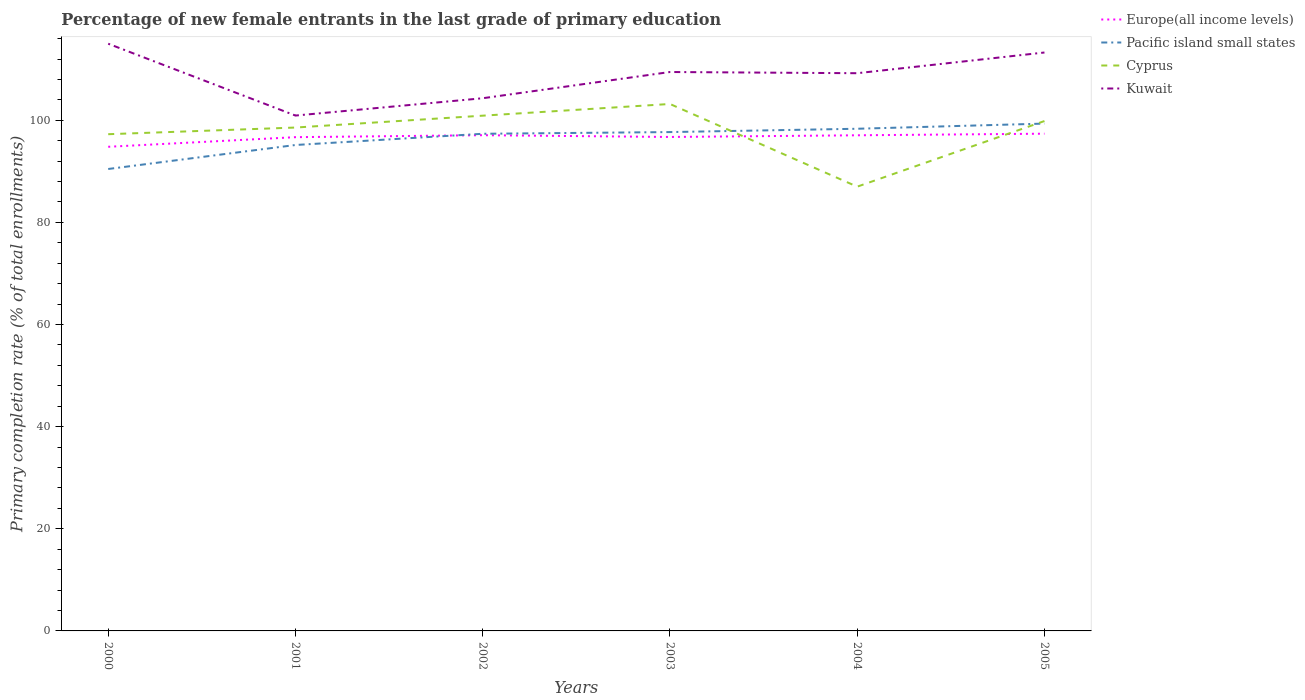Is the number of lines equal to the number of legend labels?
Provide a succinct answer. Yes. Across all years, what is the maximum percentage of new female entrants in Europe(all income levels)?
Ensure brevity in your answer.  94.81. In which year was the percentage of new female entrants in Cyprus maximum?
Offer a terse response. 2004. What is the total percentage of new female entrants in Kuwait in the graph?
Keep it short and to the point. -3.82. What is the difference between the highest and the second highest percentage of new female entrants in Kuwait?
Offer a very short reply. 14.07. What is the difference between the highest and the lowest percentage of new female entrants in Pacific island small states?
Offer a very short reply. 4. Is the percentage of new female entrants in Europe(all income levels) strictly greater than the percentage of new female entrants in Kuwait over the years?
Offer a terse response. Yes. Are the values on the major ticks of Y-axis written in scientific E-notation?
Provide a short and direct response. No. Does the graph contain any zero values?
Ensure brevity in your answer.  No. Where does the legend appear in the graph?
Offer a terse response. Top right. What is the title of the graph?
Offer a very short reply. Percentage of new female entrants in the last grade of primary education. Does "Syrian Arab Republic" appear as one of the legend labels in the graph?
Provide a succinct answer. No. What is the label or title of the Y-axis?
Make the answer very short. Primary completion rate (% of total enrollments). What is the Primary completion rate (% of total enrollments) of Europe(all income levels) in 2000?
Keep it short and to the point. 94.81. What is the Primary completion rate (% of total enrollments) in Pacific island small states in 2000?
Provide a succinct answer. 90.46. What is the Primary completion rate (% of total enrollments) in Cyprus in 2000?
Your response must be concise. 97.27. What is the Primary completion rate (% of total enrollments) in Kuwait in 2000?
Provide a short and direct response. 114.99. What is the Primary completion rate (% of total enrollments) in Europe(all income levels) in 2001?
Keep it short and to the point. 96.69. What is the Primary completion rate (% of total enrollments) of Pacific island small states in 2001?
Offer a very short reply. 95.16. What is the Primary completion rate (% of total enrollments) in Cyprus in 2001?
Offer a terse response. 98.58. What is the Primary completion rate (% of total enrollments) in Kuwait in 2001?
Keep it short and to the point. 100.93. What is the Primary completion rate (% of total enrollments) of Europe(all income levels) in 2002?
Ensure brevity in your answer.  97.08. What is the Primary completion rate (% of total enrollments) in Pacific island small states in 2002?
Your answer should be compact. 97.36. What is the Primary completion rate (% of total enrollments) in Cyprus in 2002?
Provide a short and direct response. 100.9. What is the Primary completion rate (% of total enrollments) of Kuwait in 2002?
Ensure brevity in your answer.  104.32. What is the Primary completion rate (% of total enrollments) in Europe(all income levels) in 2003?
Make the answer very short. 96.73. What is the Primary completion rate (% of total enrollments) of Pacific island small states in 2003?
Make the answer very short. 97.69. What is the Primary completion rate (% of total enrollments) of Cyprus in 2003?
Offer a very short reply. 103.19. What is the Primary completion rate (% of total enrollments) of Kuwait in 2003?
Provide a short and direct response. 109.45. What is the Primary completion rate (% of total enrollments) of Europe(all income levels) in 2004?
Give a very brief answer. 97.06. What is the Primary completion rate (% of total enrollments) of Pacific island small states in 2004?
Provide a short and direct response. 98.34. What is the Primary completion rate (% of total enrollments) in Cyprus in 2004?
Offer a very short reply. 87. What is the Primary completion rate (% of total enrollments) in Kuwait in 2004?
Offer a terse response. 109.22. What is the Primary completion rate (% of total enrollments) in Europe(all income levels) in 2005?
Offer a terse response. 97.37. What is the Primary completion rate (% of total enrollments) in Pacific island small states in 2005?
Keep it short and to the point. 99.35. What is the Primary completion rate (% of total enrollments) of Cyprus in 2005?
Ensure brevity in your answer.  99.85. What is the Primary completion rate (% of total enrollments) in Kuwait in 2005?
Make the answer very short. 113.27. Across all years, what is the maximum Primary completion rate (% of total enrollments) in Europe(all income levels)?
Give a very brief answer. 97.37. Across all years, what is the maximum Primary completion rate (% of total enrollments) of Pacific island small states?
Make the answer very short. 99.35. Across all years, what is the maximum Primary completion rate (% of total enrollments) in Cyprus?
Keep it short and to the point. 103.19. Across all years, what is the maximum Primary completion rate (% of total enrollments) of Kuwait?
Keep it short and to the point. 114.99. Across all years, what is the minimum Primary completion rate (% of total enrollments) of Europe(all income levels)?
Provide a succinct answer. 94.81. Across all years, what is the minimum Primary completion rate (% of total enrollments) in Pacific island small states?
Ensure brevity in your answer.  90.46. Across all years, what is the minimum Primary completion rate (% of total enrollments) of Cyprus?
Make the answer very short. 87. Across all years, what is the minimum Primary completion rate (% of total enrollments) in Kuwait?
Provide a succinct answer. 100.93. What is the total Primary completion rate (% of total enrollments) of Europe(all income levels) in the graph?
Ensure brevity in your answer.  579.75. What is the total Primary completion rate (% of total enrollments) of Pacific island small states in the graph?
Your response must be concise. 578.36. What is the total Primary completion rate (% of total enrollments) of Cyprus in the graph?
Keep it short and to the point. 586.8. What is the total Primary completion rate (% of total enrollments) of Kuwait in the graph?
Offer a terse response. 652.18. What is the difference between the Primary completion rate (% of total enrollments) of Europe(all income levels) in 2000 and that in 2001?
Offer a terse response. -1.88. What is the difference between the Primary completion rate (% of total enrollments) of Pacific island small states in 2000 and that in 2001?
Ensure brevity in your answer.  -4.7. What is the difference between the Primary completion rate (% of total enrollments) in Cyprus in 2000 and that in 2001?
Ensure brevity in your answer.  -1.31. What is the difference between the Primary completion rate (% of total enrollments) of Kuwait in 2000 and that in 2001?
Your response must be concise. 14.07. What is the difference between the Primary completion rate (% of total enrollments) of Europe(all income levels) in 2000 and that in 2002?
Offer a very short reply. -2.27. What is the difference between the Primary completion rate (% of total enrollments) in Pacific island small states in 2000 and that in 2002?
Provide a short and direct response. -6.9. What is the difference between the Primary completion rate (% of total enrollments) in Cyprus in 2000 and that in 2002?
Give a very brief answer. -3.63. What is the difference between the Primary completion rate (% of total enrollments) of Kuwait in 2000 and that in 2002?
Provide a succinct answer. 10.68. What is the difference between the Primary completion rate (% of total enrollments) in Europe(all income levels) in 2000 and that in 2003?
Ensure brevity in your answer.  -1.92. What is the difference between the Primary completion rate (% of total enrollments) in Pacific island small states in 2000 and that in 2003?
Give a very brief answer. -7.23. What is the difference between the Primary completion rate (% of total enrollments) of Cyprus in 2000 and that in 2003?
Ensure brevity in your answer.  -5.92. What is the difference between the Primary completion rate (% of total enrollments) of Kuwait in 2000 and that in 2003?
Offer a terse response. 5.54. What is the difference between the Primary completion rate (% of total enrollments) in Europe(all income levels) in 2000 and that in 2004?
Offer a terse response. -2.25. What is the difference between the Primary completion rate (% of total enrollments) in Pacific island small states in 2000 and that in 2004?
Your response must be concise. -7.88. What is the difference between the Primary completion rate (% of total enrollments) in Cyprus in 2000 and that in 2004?
Give a very brief answer. 10.27. What is the difference between the Primary completion rate (% of total enrollments) of Kuwait in 2000 and that in 2004?
Make the answer very short. 5.78. What is the difference between the Primary completion rate (% of total enrollments) in Europe(all income levels) in 2000 and that in 2005?
Your answer should be compact. -2.56. What is the difference between the Primary completion rate (% of total enrollments) of Pacific island small states in 2000 and that in 2005?
Make the answer very short. -8.89. What is the difference between the Primary completion rate (% of total enrollments) in Cyprus in 2000 and that in 2005?
Provide a succinct answer. -2.58. What is the difference between the Primary completion rate (% of total enrollments) in Kuwait in 2000 and that in 2005?
Make the answer very short. 1.72. What is the difference between the Primary completion rate (% of total enrollments) in Europe(all income levels) in 2001 and that in 2002?
Provide a short and direct response. -0.39. What is the difference between the Primary completion rate (% of total enrollments) of Pacific island small states in 2001 and that in 2002?
Make the answer very short. -2.2. What is the difference between the Primary completion rate (% of total enrollments) of Cyprus in 2001 and that in 2002?
Give a very brief answer. -2.32. What is the difference between the Primary completion rate (% of total enrollments) in Kuwait in 2001 and that in 2002?
Offer a very short reply. -3.39. What is the difference between the Primary completion rate (% of total enrollments) in Europe(all income levels) in 2001 and that in 2003?
Offer a very short reply. -0.04. What is the difference between the Primary completion rate (% of total enrollments) in Pacific island small states in 2001 and that in 2003?
Offer a very short reply. -2.53. What is the difference between the Primary completion rate (% of total enrollments) in Cyprus in 2001 and that in 2003?
Make the answer very short. -4.61. What is the difference between the Primary completion rate (% of total enrollments) of Kuwait in 2001 and that in 2003?
Your response must be concise. -8.53. What is the difference between the Primary completion rate (% of total enrollments) of Europe(all income levels) in 2001 and that in 2004?
Provide a short and direct response. -0.37. What is the difference between the Primary completion rate (% of total enrollments) in Pacific island small states in 2001 and that in 2004?
Offer a very short reply. -3.18. What is the difference between the Primary completion rate (% of total enrollments) of Cyprus in 2001 and that in 2004?
Ensure brevity in your answer.  11.58. What is the difference between the Primary completion rate (% of total enrollments) in Kuwait in 2001 and that in 2004?
Your answer should be very brief. -8.29. What is the difference between the Primary completion rate (% of total enrollments) in Europe(all income levels) in 2001 and that in 2005?
Offer a terse response. -0.68. What is the difference between the Primary completion rate (% of total enrollments) of Pacific island small states in 2001 and that in 2005?
Your response must be concise. -4.19. What is the difference between the Primary completion rate (% of total enrollments) of Cyprus in 2001 and that in 2005?
Offer a terse response. -1.27. What is the difference between the Primary completion rate (% of total enrollments) of Kuwait in 2001 and that in 2005?
Give a very brief answer. -12.35. What is the difference between the Primary completion rate (% of total enrollments) in Europe(all income levels) in 2002 and that in 2003?
Give a very brief answer. 0.35. What is the difference between the Primary completion rate (% of total enrollments) of Pacific island small states in 2002 and that in 2003?
Give a very brief answer. -0.33. What is the difference between the Primary completion rate (% of total enrollments) in Cyprus in 2002 and that in 2003?
Offer a very short reply. -2.29. What is the difference between the Primary completion rate (% of total enrollments) in Kuwait in 2002 and that in 2003?
Provide a succinct answer. -5.14. What is the difference between the Primary completion rate (% of total enrollments) of Europe(all income levels) in 2002 and that in 2004?
Make the answer very short. 0.02. What is the difference between the Primary completion rate (% of total enrollments) in Pacific island small states in 2002 and that in 2004?
Your response must be concise. -0.98. What is the difference between the Primary completion rate (% of total enrollments) of Cyprus in 2002 and that in 2004?
Your answer should be very brief. 13.9. What is the difference between the Primary completion rate (% of total enrollments) in Kuwait in 2002 and that in 2004?
Offer a terse response. -4.9. What is the difference between the Primary completion rate (% of total enrollments) of Europe(all income levels) in 2002 and that in 2005?
Ensure brevity in your answer.  -0.29. What is the difference between the Primary completion rate (% of total enrollments) in Pacific island small states in 2002 and that in 2005?
Keep it short and to the point. -1.99. What is the difference between the Primary completion rate (% of total enrollments) of Cyprus in 2002 and that in 2005?
Give a very brief answer. 1.05. What is the difference between the Primary completion rate (% of total enrollments) of Kuwait in 2002 and that in 2005?
Give a very brief answer. -8.96. What is the difference between the Primary completion rate (% of total enrollments) of Europe(all income levels) in 2003 and that in 2004?
Make the answer very short. -0.33. What is the difference between the Primary completion rate (% of total enrollments) of Pacific island small states in 2003 and that in 2004?
Ensure brevity in your answer.  -0.65. What is the difference between the Primary completion rate (% of total enrollments) in Cyprus in 2003 and that in 2004?
Make the answer very short. 16.19. What is the difference between the Primary completion rate (% of total enrollments) in Kuwait in 2003 and that in 2004?
Ensure brevity in your answer.  0.24. What is the difference between the Primary completion rate (% of total enrollments) of Europe(all income levels) in 2003 and that in 2005?
Your response must be concise. -0.64. What is the difference between the Primary completion rate (% of total enrollments) of Pacific island small states in 2003 and that in 2005?
Keep it short and to the point. -1.66. What is the difference between the Primary completion rate (% of total enrollments) of Cyprus in 2003 and that in 2005?
Provide a succinct answer. 3.34. What is the difference between the Primary completion rate (% of total enrollments) of Kuwait in 2003 and that in 2005?
Your answer should be very brief. -3.82. What is the difference between the Primary completion rate (% of total enrollments) of Europe(all income levels) in 2004 and that in 2005?
Ensure brevity in your answer.  -0.31. What is the difference between the Primary completion rate (% of total enrollments) of Pacific island small states in 2004 and that in 2005?
Offer a very short reply. -1.01. What is the difference between the Primary completion rate (% of total enrollments) of Cyprus in 2004 and that in 2005?
Make the answer very short. -12.85. What is the difference between the Primary completion rate (% of total enrollments) of Kuwait in 2004 and that in 2005?
Your response must be concise. -4.06. What is the difference between the Primary completion rate (% of total enrollments) of Europe(all income levels) in 2000 and the Primary completion rate (% of total enrollments) of Pacific island small states in 2001?
Your answer should be compact. -0.35. What is the difference between the Primary completion rate (% of total enrollments) of Europe(all income levels) in 2000 and the Primary completion rate (% of total enrollments) of Cyprus in 2001?
Provide a short and direct response. -3.77. What is the difference between the Primary completion rate (% of total enrollments) in Europe(all income levels) in 2000 and the Primary completion rate (% of total enrollments) in Kuwait in 2001?
Provide a short and direct response. -6.12. What is the difference between the Primary completion rate (% of total enrollments) in Pacific island small states in 2000 and the Primary completion rate (% of total enrollments) in Cyprus in 2001?
Provide a short and direct response. -8.12. What is the difference between the Primary completion rate (% of total enrollments) in Pacific island small states in 2000 and the Primary completion rate (% of total enrollments) in Kuwait in 2001?
Offer a terse response. -10.46. What is the difference between the Primary completion rate (% of total enrollments) of Cyprus in 2000 and the Primary completion rate (% of total enrollments) of Kuwait in 2001?
Make the answer very short. -3.65. What is the difference between the Primary completion rate (% of total enrollments) of Europe(all income levels) in 2000 and the Primary completion rate (% of total enrollments) of Pacific island small states in 2002?
Keep it short and to the point. -2.55. What is the difference between the Primary completion rate (% of total enrollments) of Europe(all income levels) in 2000 and the Primary completion rate (% of total enrollments) of Cyprus in 2002?
Offer a very short reply. -6.09. What is the difference between the Primary completion rate (% of total enrollments) of Europe(all income levels) in 2000 and the Primary completion rate (% of total enrollments) of Kuwait in 2002?
Provide a short and direct response. -9.51. What is the difference between the Primary completion rate (% of total enrollments) in Pacific island small states in 2000 and the Primary completion rate (% of total enrollments) in Cyprus in 2002?
Provide a succinct answer. -10.44. What is the difference between the Primary completion rate (% of total enrollments) of Pacific island small states in 2000 and the Primary completion rate (% of total enrollments) of Kuwait in 2002?
Give a very brief answer. -13.86. What is the difference between the Primary completion rate (% of total enrollments) in Cyprus in 2000 and the Primary completion rate (% of total enrollments) in Kuwait in 2002?
Provide a succinct answer. -7.04. What is the difference between the Primary completion rate (% of total enrollments) in Europe(all income levels) in 2000 and the Primary completion rate (% of total enrollments) in Pacific island small states in 2003?
Make the answer very short. -2.88. What is the difference between the Primary completion rate (% of total enrollments) of Europe(all income levels) in 2000 and the Primary completion rate (% of total enrollments) of Cyprus in 2003?
Offer a very short reply. -8.38. What is the difference between the Primary completion rate (% of total enrollments) in Europe(all income levels) in 2000 and the Primary completion rate (% of total enrollments) in Kuwait in 2003?
Offer a very short reply. -14.64. What is the difference between the Primary completion rate (% of total enrollments) in Pacific island small states in 2000 and the Primary completion rate (% of total enrollments) in Cyprus in 2003?
Provide a short and direct response. -12.73. What is the difference between the Primary completion rate (% of total enrollments) of Pacific island small states in 2000 and the Primary completion rate (% of total enrollments) of Kuwait in 2003?
Your answer should be compact. -18.99. What is the difference between the Primary completion rate (% of total enrollments) in Cyprus in 2000 and the Primary completion rate (% of total enrollments) in Kuwait in 2003?
Ensure brevity in your answer.  -12.18. What is the difference between the Primary completion rate (% of total enrollments) of Europe(all income levels) in 2000 and the Primary completion rate (% of total enrollments) of Pacific island small states in 2004?
Your response must be concise. -3.53. What is the difference between the Primary completion rate (% of total enrollments) of Europe(all income levels) in 2000 and the Primary completion rate (% of total enrollments) of Cyprus in 2004?
Your response must be concise. 7.81. What is the difference between the Primary completion rate (% of total enrollments) of Europe(all income levels) in 2000 and the Primary completion rate (% of total enrollments) of Kuwait in 2004?
Your response must be concise. -14.41. What is the difference between the Primary completion rate (% of total enrollments) of Pacific island small states in 2000 and the Primary completion rate (% of total enrollments) of Cyprus in 2004?
Offer a very short reply. 3.46. What is the difference between the Primary completion rate (% of total enrollments) of Pacific island small states in 2000 and the Primary completion rate (% of total enrollments) of Kuwait in 2004?
Ensure brevity in your answer.  -18.76. What is the difference between the Primary completion rate (% of total enrollments) of Cyprus in 2000 and the Primary completion rate (% of total enrollments) of Kuwait in 2004?
Keep it short and to the point. -11.94. What is the difference between the Primary completion rate (% of total enrollments) in Europe(all income levels) in 2000 and the Primary completion rate (% of total enrollments) in Pacific island small states in 2005?
Make the answer very short. -4.54. What is the difference between the Primary completion rate (% of total enrollments) in Europe(all income levels) in 2000 and the Primary completion rate (% of total enrollments) in Cyprus in 2005?
Offer a terse response. -5.04. What is the difference between the Primary completion rate (% of total enrollments) of Europe(all income levels) in 2000 and the Primary completion rate (% of total enrollments) of Kuwait in 2005?
Offer a very short reply. -18.46. What is the difference between the Primary completion rate (% of total enrollments) of Pacific island small states in 2000 and the Primary completion rate (% of total enrollments) of Cyprus in 2005?
Your response must be concise. -9.39. What is the difference between the Primary completion rate (% of total enrollments) in Pacific island small states in 2000 and the Primary completion rate (% of total enrollments) in Kuwait in 2005?
Ensure brevity in your answer.  -22.81. What is the difference between the Primary completion rate (% of total enrollments) in Cyprus in 2000 and the Primary completion rate (% of total enrollments) in Kuwait in 2005?
Keep it short and to the point. -16. What is the difference between the Primary completion rate (% of total enrollments) of Europe(all income levels) in 2001 and the Primary completion rate (% of total enrollments) of Pacific island small states in 2002?
Your answer should be very brief. -0.66. What is the difference between the Primary completion rate (% of total enrollments) in Europe(all income levels) in 2001 and the Primary completion rate (% of total enrollments) in Cyprus in 2002?
Your answer should be very brief. -4.21. What is the difference between the Primary completion rate (% of total enrollments) in Europe(all income levels) in 2001 and the Primary completion rate (% of total enrollments) in Kuwait in 2002?
Provide a succinct answer. -7.62. What is the difference between the Primary completion rate (% of total enrollments) in Pacific island small states in 2001 and the Primary completion rate (% of total enrollments) in Cyprus in 2002?
Offer a terse response. -5.74. What is the difference between the Primary completion rate (% of total enrollments) in Pacific island small states in 2001 and the Primary completion rate (% of total enrollments) in Kuwait in 2002?
Give a very brief answer. -9.16. What is the difference between the Primary completion rate (% of total enrollments) in Cyprus in 2001 and the Primary completion rate (% of total enrollments) in Kuwait in 2002?
Make the answer very short. -5.74. What is the difference between the Primary completion rate (% of total enrollments) in Europe(all income levels) in 2001 and the Primary completion rate (% of total enrollments) in Pacific island small states in 2003?
Offer a terse response. -1. What is the difference between the Primary completion rate (% of total enrollments) of Europe(all income levels) in 2001 and the Primary completion rate (% of total enrollments) of Cyprus in 2003?
Offer a terse response. -6.5. What is the difference between the Primary completion rate (% of total enrollments) of Europe(all income levels) in 2001 and the Primary completion rate (% of total enrollments) of Kuwait in 2003?
Give a very brief answer. -12.76. What is the difference between the Primary completion rate (% of total enrollments) in Pacific island small states in 2001 and the Primary completion rate (% of total enrollments) in Cyprus in 2003?
Provide a short and direct response. -8.03. What is the difference between the Primary completion rate (% of total enrollments) of Pacific island small states in 2001 and the Primary completion rate (% of total enrollments) of Kuwait in 2003?
Your response must be concise. -14.29. What is the difference between the Primary completion rate (% of total enrollments) in Cyprus in 2001 and the Primary completion rate (% of total enrollments) in Kuwait in 2003?
Ensure brevity in your answer.  -10.88. What is the difference between the Primary completion rate (% of total enrollments) in Europe(all income levels) in 2001 and the Primary completion rate (% of total enrollments) in Pacific island small states in 2004?
Provide a short and direct response. -1.65. What is the difference between the Primary completion rate (% of total enrollments) of Europe(all income levels) in 2001 and the Primary completion rate (% of total enrollments) of Cyprus in 2004?
Provide a succinct answer. 9.69. What is the difference between the Primary completion rate (% of total enrollments) in Europe(all income levels) in 2001 and the Primary completion rate (% of total enrollments) in Kuwait in 2004?
Your answer should be very brief. -12.52. What is the difference between the Primary completion rate (% of total enrollments) in Pacific island small states in 2001 and the Primary completion rate (% of total enrollments) in Cyprus in 2004?
Make the answer very short. 8.16. What is the difference between the Primary completion rate (% of total enrollments) in Pacific island small states in 2001 and the Primary completion rate (% of total enrollments) in Kuwait in 2004?
Ensure brevity in your answer.  -14.06. What is the difference between the Primary completion rate (% of total enrollments) in Cyprus in 2001 and the Primary completion rate (% of total enrollments) in Kuwait in 2004?
Ensure brevity in your answer.  -10.64. What is the difference between the Primary completion rate (% of total enrollments) in Europe(all income levels) in 2001 and the Primary completion rate (% of total enrollments) in Pacific island small states in 2005?
Give a very brief answer. -2.66. What is the difference between the Primary completion rate (% of total enrollments) of Europe(all income levels) in 2001 and the Primary completion rate (% of total enrollments) of Cyprus in 2005?
Provide a succinct answer. -3.16. What is the difference between the Primary completion rate (% of total enrollments) of Europe(all income levels) in 2001 and the Primary completion rate (% of total enrollments) of Kuwait in 2005?
Ensure brevity in your answer.  -16.58. What is the difference between the Primary completion rate (% of total enrollments) of Pacific island small states in 2001 and the Primary completion rate (% of total enrollments) of Cyprus in 2005?
Make the answer very short. -4.69. What is the difference between the Primary completion rate (% of total enrollments) of Pacific island small states in 2001 and the Primary completion rate (% of total enrollments) of Kuwait in 2005?
Ensure brevity in your answer.  -18.11. What is the difference between the Primary completion rate (% of total enrollments) of Cyprus in 2001 and the Primary completion rate (% of total enrollments) of Kuwait in 2005?
Make the answer very short. -14.69. What is the difference between the Primary completion rate (% of total enrollments) of Europe(all income levels) in 2002 and the Primary completion rate (% of total enrollments) of Pacific island small states in 2003?
Give a very brief answer. -0.61. What is the difference between the Primary completion rate (% of total enrollments) of Europe(all income levels) in 2002 and the Primary completion rate (% of total enrollments) of Cyprus in 2003?
Your response must be concise. -6.11. What is the difference between the Primary completion rate (% of total enrollments) of Europe(all income levels) in 2002 and the Primary completion rate (% of total enrollments) of Kuwait in 2003?
Your answer should be very brief. -12.37. What is the difference between the Primary completion rate (% of total enrollments) of Pacific island small states in 2002 and the Primary completion rate (% of total enrollments) of Cyprus in 2003?
Your answer should be compact. -5.84. What is the difference between the Primary completion rate (% of total enrollments) in Pacific island small states in 2002 and the Primary completion rate (% of total enrollments) in Kuwait in 2003?
Offer a very short reply. -12.1. What is the difference between the Primary completion rate (% of total enrollments) in Cyprus in 2002 and the Primary completion rate (% of total enrollments) in Kuwait in 2003?
Provide a succinct answer. -8.55. What is the difference between the Primary completion rate (% of total enrollments) in Europe(all income levels) in 2002 and the Primary completion rate (% of total enrollments) in Pacific island small states in 2004?
Your response must be concise. -1.26. What is the difference between the Primary completion rate (% of total enrollments) of Europe(all income levels) in 2002 and the Primary completion rate (% of total enrollments) of Cyprus in 2004?
Your answer should be compact. 10.08. What is the difference between the Primary completion rate (% of total enrollments) in Europe(all income levels) in 2002 and the Primary completion rate (% of total enrollments) in Kuwait in 2004?
Offer a terse response. -12.14. What is the difference between the Primary completion rate (% of total enrollments) in Pacific island small states in 2002 and the Primary completion rate (% of total enrollments) in Cyprus in 2004?
Offer a very short reply. 10.36. What is the difference between the Primary completion rate (% of total enrollments) of Pacific island small states in 2002 and the Primary completion rate (% of total enrollments) of Kuwait in 2004?
Provide a short and direct response. -11.86. What is the difference between the Primary completion rate (% of total enrollments) of Cyprus in 2002 and the Primary completion rate (% of total enrollments) of Kuwait in 2004?
Offer a terse response. -8.31. What is the difference between the Primary completion rate (% of total enrollments) in Europe(all income levels) in 2002 and the Primary completion rate (% of total enrollments) in Pacific island small states in 2005?
Provide a succinct answer. -2.27. What is the difference between the Primary completion rate (% of total enrollments) in Europe(all income levels) in 2002 and the Primary completion rate (% of total enrollments) in Cyprus in 2005?
Your answer should be compact. -2.77. What is the difference between the Primary completion rate (% of total enrollments) in Europe(all income levels) in 2002 and the Primary completion rate (% of total enrollments) in Kuwait in 2005?
Provide a short and direct response. -16.19. What is the difference between the Primary completion rate (% of total enrollments) of Pacific island small states in 2002 and the Primary completion rate (% of total enrollments) of Cyprus in 2005?
Your answer should be compact. -2.49. What is the difference between the Primary completion rate (% of total enrollments) in Pacific island small states in 2002 and the Primary completion rate (% of total enrollments) in Kuwait in 2005?
Offer a very short reply. -15.92. What is the difference between the Primary completion rate (% of total enrollments) of Cyprus in 2002 and the Primary completion rate (% of total enrollments) of Kuwait in 2005?
Offer a very short reply. -12.37. What is the difference between the Primary completion rate (% of total enrollments) of Europe(all income levels) in 2003 and the Primary completion rate (% of total enrollments) of Pacific island small states in 2004?
Provide a short and direct response. -1.61. What is the difference between the Primary completion rate (% of total enrollments) in Europe(all income levels) in 2003 and the Primary completion rate (% of total enrollments) in Cyprus in 2004?
Offer a very short reply. 9.73. What is the difference between the Primary completion rate (% of total enrollments) in Europe(all income levels) in 2003 and the Primary completion rate (% of total enrollments) in Kuwait in 2004?
Provide a short and direct response. -12.48. What is the difference between the Primary completion rate (% of total enrollments) in Pacific island small states in 2003 and the Primary completion rate (% of total enrollments) in Cyprus in 2004?
Your response must be concise. 10.69. What is the difference between the Primary completion rate (% of total enrollments) in Pacific island small states in 2003 and the Primary completion rate (% of total enrollments) in Kuwait in 2004?
Offer a very short reply. -11.53. What is the difference between the Primary completion rate (% of total enrollments) of Cyprus in 2003 and the Primary completion rate (% of total enrollments) of Kuwait in 2004?
Provide a short and direct response. -6.02. What is the difference between the Primary completion rate (% of total enrollments) of Europe(all income levels) in 2003 and the Primary completion rate (% of total enrollments) of Pacific island small states in 2005?
Your answer should be compact. -2.62. What is the difference between the Primary completion rate (% of total enrollments) of Europe(all income levels) in 2003 and the Primary completion rate (% of total enrollments) of Cyprus in 2005?
Provide a succinct answer. -3.12. What is the difference between the Primary completion rate (% of total enrollments) of Europe(all income levels) in 2003 and the Primary completion rate (% of total enrollments) of Kuwait in 2005?
Make the answer very short. -16.54. What is the difference between the Primary completion rate (% of total enrollments) in Pacific island small states in 2003 and the Primary completion rate (% of total enrollments) in Cyprus in 2005?
Offer a very short reply. -2.16. What is the difference between the Primary completion rate (% of total enrollments) in Pacific island small states in 2003 and the Primary completion rate (% of total enrollments) in Kuwait in 2005?
Your answer should be compact. -15.58. What is the difference between the Primary completion rate (% of total enrollments) of Cyprus in 2003 and the Primary completion rate (% of total enrollments) of Kuwait in 2005?
Your response must be concise. -10.08. What is the difference between the Primary completion rate (% of total enrollments) in Europe(all income levels) in 2004 and the Primary completion rate (% of total enrollments) in Pacific island small states in 2005?
Keep it short and to the point. -2.29. What is the difference between the Primary completion rate (% of total enrollments) of Europe(all income levels) in 2004 and the Primary completion rate (% of total enrollments) of Cyprus in 2005?
Keep it short and to the point. -2.79. What is the difference between the Primary completion rate (% of total enrollments) in Europe(all income levels) in 2004 and the Primary completion rate (% of total enrollments) in Kuwait in 2005?
Make the answer very short. -16.21. What is the difference between the Primary completion rate (% of total enrollments) of Pacific island small states in 2004 and the Primary completion rate (% of total enrollments) of Cyprus in 2005?
Provide a succinct answer. -1.51. What is the difference between the Primary completion rate (% of total enrollments) of Pacific island small states in 2004 and the Primary completion rate (% of total enrollments) of Kuwait in 2005?
Your response must be concise. -14.93. What is the difference between the Primary completion rate (% of total enrollments) of Cyprus in 2004 and the Primary completion rate (% of total enrollments) of Kuwait in 2005?
Ensure brevity in your answer.  -26.27. What is the average Primary completion rate (% of total enrollments) in Europe(all income levels) per year?
Give a very brief answer. 96.62. What is the average Primary completion rate (% of total enrollments) in Pacific island small states per year?
Give a very brief answer. 96.39. What is the average Primary completion rate (% of total enrollments) in Cyprus per year?
Offer a very short reply. 97.8. What is the average Primary completion rate (% of total enrollments) of Kuwait per year?
Offer a very short reply. 108.7. In the year 2000, what is the difference between the Primary completion rate (% of total enrollments) of Europe(all income levels) and Primary completion rate (% of total enrollments) of Pacific island small states?
Provide a short and direct response. 4.35. In the year 2000, what is the difference between the Primary completion rate (% of total enrollments) of Europe(all income levels) and Primary completion rate (% of total enrollments) of Cyprus?
Keep it short and to the point. -2.46. In the year 2000, what is the difference between the Primary completion rate (% of total enrollments) of Europe(all income levels) and Primary completion rate (% of total enrollments) of Kuwait?
Your answer should be compact. -20.18. In the year 2000, what is the difference between the Primary completion rate (% of total enrollments) of Pacific island small states and Primary completion rate (% of total enrollments) of Cyprus?
Offer a very short reply. -6.81. In the year 2000, what is the difference between the Primary completion rate (% of total enrollments) in Pacific island small states and Primary completion rate (% of total enrollments) in Kuwait?
Your answer should be very brief. -24.53. In the year 2000, what is the difference between the Primary completion rate (% of total enrollments) of Cyprus and Primary completion rate (% of total enrollments) of Kuwait?
Provide a succinct answer. -17.72. In the year 2001, what is the difference between the Primary completion rate (% of total enrollments) of Europe(all income levels) and Primary completion rate (% of total enrollments) of Pacific island small states?
Offer a terse response. 1.53. In the year 2001, what is the difference between the Primary completion rate (% of total enrollments) of Europe(all income levels) and Primary completion rate (% of total enrollments) of Cyprus?
Provide a succinct answer. -1.89. In the year 2001, what is the difference between the Primary completion rate (% of total enrollments) of Europe(all income levels) and Primary completion rate (% of total enrollments) of Kuwait?
Offer a very short reply. -4.23. In the year 2001, what is the difference between the Primary completion rate (% of total enrollments) of Pacific island small states and Primary completion rate (% of total enrollments) of Cyprus?
Your answer should be compact. -3.42. In the year 2001, what is the difference between the Primary completion rate (% of total enrollments) of Pacific island small states and Primary completion rate (% of total enrollments) of Kuwait?
Make the answer very short. -5.77. In the year 2001, what is the difference between the Primary completion rate (% of total enrollments) of Cyprus and Primary completion rate (% of total enrollments) of Kuwait?
Your answer should be compact. -2.35. In the year 2002, what is the difference between the Primary completion rate (% of total enrollments) in Europe(all income levels) and Primary completion rate (% of total enrollments) in Pacific island small states?
Your answer should be compact. -0.28. In the year 2002, what is the difference between the Primary completion rate (% of total enrollments) of Europe(all income levels) and Primary completion rate (% of total enrollments) of Cyprus?
Provide a short and direct response. -3.82. In the year 2002, what is the difference between the Primary completion rate (% of total enrollments) of Europe(all income levels) and Primary completion rate (% of total enrollments) of Kuwait?
Provide a succinct answer. -7.24. In the year 2002, what is the difference between the Primary completion rate (% of total enrollments) of Pacific island small states and Primary completion rate (% of total enrollments) of Cyprus?
Provide a succinct answer. -3.55. In the year 2002, what is the difference between the Primary completion rate (% of total enrollments) in Pacific island small states and Primary completion rate (% of total enrollments) in Kuwait?
Provide a short and direct response. -6.96. In the year 2002, what is the difference between the Primary completion rate (% of total enrollments) in Cyprus and Primary completion rate (% of total enrollments) in Kuwait?
Keep it short and to the point. -3.41. In the year 2003, what is the difference between the Primary completion rate (% of total enrollments) of Europe(all income levels) and Primary completion rate (% of total enrollments) of Pacific island small states?
Provide a succinct answer. -0.96. In the year 2003, what is the difference between the Primary completion rate (% of total enrollments) of Europe(all income levels) and Primary completion rate (% of total enrollments) of Cyprus?
Provide a succinct answer. -6.46. In the year 2003, what is the difference between the Primary completion rate (% of total enrollments) of Europe(all income levels) and Primary completion rate (% of total enrollments) of Kuwait?
Provide a succinct answer. -12.72. In the year 2003, what is the difference between the Primary completion rate (% of total enrollments) of Pacific island small states and Primary completion rate (% of total enrollments) of Cyprus?
Keep it short and to the point. -5.5. In the year 2003, what is the difference between the Primary completion rate (% of total enrollments) in Pacific island small states and Primary completion rate (% of total enrollments) in Kuwait?
Offer a very short reply. -11.76. In the year 2003, what is the difference between the Primary completion rate (% of total enrollments) in Cyprus and Primary completion rate (% of total enrollments) in Kuwait?
Offer a very short reply. -6.26. In the year 2004, what is the difference between the Primary completion rate (% of total enrollments) in Europe(all income levels) and Primary completion rate (% of total enrollments) in Pacific island small states?
Keep it short and to the point. -1.28. In the year 2004, what is the difference between the Primary completion rate (% of total enrollments) of Europe(all income levels) and Primary completion rate (% of total enrollments) of Cyprus?
Ensure brevity in your answer.  10.06. In the year 2004, what is the difference between the Primary completion rate (% of total enrollments) in Europe(all income levels) and Primary completion rate (% of total enrollments) in Kuwait?
Your answer should be very brief. -12.16. In the year 2004, what is the difference between the Primary completion rate (% of total enrollments) in Pacific island small states and Primary completion rate (% of total enrollments) in Cyprus?
Your answer should be very brief. 11.34. In the year 2004, what is the difference between the Primary completion rate (% of total enrollments) of Pacific island small states and Primary completion rate (% of total enrollments) of Kuwait?
Give a very brief answer. -10.88. In the year 2004, what is the difference between the Primary completion rate (% of total enrollments) in Cyprus and Primary completion rate (% of total enrollments) in Kuwait?
Keep it short and to the point. -22.22. In the year 2005, what is the difference between the Primary completion rate (% of total enrollments) in Europe(all income levels) and Primary completion rate (% of total enrollments) in Pacific island small states?
Keep it short and to the point. -1.98. In the year 2005, what is the difference between the Primary completion rate (% of total enrollments) in Europe(all income levels) and Primary completion rate (% of total enrollments) in Cyprus?
Provide a succinct answer. -2.48. In the year 2005, what is the difference between the Primary completion rate (% of total enrollments) of Europe(all income levels) and Primary completion rate (% of total enrollments) of Kuwait?
Provide a succinct answer. -15.9. In the year 2005, what is the difference between the Primary completion rate (% of total enrollments) in Pacific island small states and Primary completion rate (% of total enrollments) in Cyprus?
Your response must be concise. -0.5. In the year 2005, what is the difference between the Primary completion rate (% of total enrollments) of Pacific island small states and Primary completion rate (% of total enrollments) of Kuwait?
Provide a short and direct response. -13.92. In the year 2005, what is the difference between the Primary completion rate (% of total enrollments) in Cyprus and Primary completion rate (% of total enrollments) in Kuwait?
Offer a terse response. -13.42. What is the ratio of the Primary completion rate (% of total enrollments) of Europe(all income levels) in 2000 to that in 2001?
Your answer should be very brief. 0.98. What is the ratio of the Primary completion rate (% of total enrollments) in Pacific island small states in 2000 to that in 2001?
Make the answer very short. 0.95. What is the ratio of the Primary completion rate (% of total enrollments) in Cyprus in 2000 to that in 2001?
Offer a very short reply. 0.99. What is the ratio of the Primary completion rate (% of total enrollments) of Kuwait in 2000 to that in 2001?
Offer a very short reply. 1.14. What is the ratio of the Primary completion rate (% of total enrollments) in Europe(all income levels) in 2000 to that in 2002?
Keep it short and to the point. 0.98. What is the ratio of the Primary completion rate (% of total enrollments) of Pacific island small states in 2000 to that in 2002?
Your answer should be compact. 0.93. What is the ratio of the Primary completion rate (% of total enrollments) of Kuwait in 2000 to that in 2002?
Your answer should be compact. 1.1. What is the ratio of the Primary completion rate (% of total enrollments) of Europe(all income levels) in 2000 to that in 2003?
Keep it short and to the point. 0.98. What is the ratio of the Primary completion rate (% of total enrollments) of Pacific island small states in 2000 to that in 2003?
Offer a very short reply. 0.93. What is the ratio of the Primary completion rate (% of total enrollments) of Cyprus in 2000 to that in 2003?
Your response must be concise. 0.94. What is the ratio of the Primary completion rate (% of total enrollments) in Kuwait in 2000 to that in 2003?
Give a very brief answer. 1.05. What is the ratio of the Primary completion rate (% of total enrollments) in Europe(all income levels) in 2000 to that in 2004?
Make the answer very short. 0.98. What is the ratio of the Primary completion rate (% of total enrollments) of Pacific island small states in 2000 to that in 2004?
Make the answer very short. 0.92. What is the ratio of the Primary completion rate (% of total enrollments) of Cyprus in 2000 to that in 2004?
Your response must be concise. 1.12. What is the ratio of the Primary completion rate (% of total enrollments) of Kuwait in 2000 to that in 2004?
Give a very brief answer. 1.05. What is the ratio of the Primary completion rate (% of total enrollments) of Europe(all income levels) in 2000 to that in 2005?
Your response must be concise. 0.97. What is the ratio of the Primary completion rate (% of total enrollments) in Pacific island small states in 2000 to that in 2005?
Give a very brief answer. 0.91. What is the ratio of the Primary completion rate (% of total enrollments) of Cyprus in 2000 to that in 2005?
Your response must be concise. 0.97. What is the ratio of the Primary completion rate (% of total enrollments) in Kuwait in 2000 to that in 2005?
Keep it short and to the point. 1.02. What is the ratio of the Primary completion rate (% of total enrollments) in Pacific island small states in 2001 to that in 2002?
Your response must be concise. 0.98. What is the ratio of the Primary completion rate (% of total enrollments) of Kuwait in 2001 to that in 2002?
Make the answer very short. 0.97. What is the ratio of the Primary completion rate (% of total enrollments) in Pacific island small states in 2001 to that in 2003?
Ensure brevity in your answer.  0.97. What is the ratio of the Primary completion rate (% of total enrollments) in Cyprus in 2001 to that in 2003?
Provide a succinct answer. 0.96. What is the ratio of the Primary completion rate (% of total enrollments) of Kuwait in 2001 to that in 2003?
Provide a short and direct response. 0.92. What is the ratio of the Primary completion rate (% of total enrollments) of Europe(all income levels) in 2001 to that in 2004?
Ensure brevity in your answer.  1. What is the ratio of the Primary completion rate (% of total enrollments) in Cyprus in 2001 to that in 2004?
Provide a succinct answer. 1.13. What is the ratio of the Primary completion rate (% of total enrollments) in Kuwait in 2001 to that in 2004?
Give a very brief answer. 0.92. What is the ratio of the Primary completion rate (% of total enrollments) in Pacific island small states in 2001 to that in 2005?
Ensure brevity in your answer.  0.96. What is the ratio of the Primary completion rate (% of total enrollments) in Cyprus in 2001 to that in 2005?
Offer a terse response. 0.99. What is the ratio of the Primary completion rate (% of total enrollments) in Kuwait in 2001 to that in 2005?
Give a very brief answer. 0.89. What is the ratio of the Primary completion rate (% of total enrollments) in Europe(all income levels) in 2002 to that in 2003?
Keep it short and to the point. 1. What is the ratio of the Primary completion rate (% of total enrollments) of Cyprus in 2002 to that in 2003?
Your response must be concise. 0.98. What is the ratio of the Primary completion rate (% of total enrollments) of Kuwait in 2002 to that in 2003?
Give a very brief answer. 0.95. What is the ratio of the Primary completion rate (% of total enrollments) in Europe(all income levels) in 2002 to that in 2004?
Make the answer very short. 1. What is the ratio of the Primary completion rate (% of total enrollments) in Cyprus in 2002 to that in 2004?
Your answer should be compact. 1.16. What is the ratio of the Primary completion rate (% of total enrollments) of Kuwait in 2002 to that in 2004?
Give a very brief answer. 0.96. What is the ratio of the Primary completion rate (% of total enrollments) in Europe(all income levels) in 2002 to that in 2005?
Your answer should be compact. 1. What is the ratio of the Primary completion rate (% of total enrollments) of Pacific island small states in 2002 to that in 2005?
Make the answer very short. 0.98. What is the ratio of the Primary completion rate (% of total enrollments) in Cyprus in 2002 to that in 2005?
Provide a succinct answer. 1.01. What is the ratio of the Primary completion rate (% of total enrollments) in Kuwait in 2002 to that in 2005?
Your response must be concise. 0.92. What is the ratio of the Primary completion rate (% of total enrollments) of Pacific island small states in 2003 to that in 2004?
Provide a succinct answer. 0.99. What is the ratio of the Primary completion rate (% of total enrollments) in Cyprus in 2003 to that in 2004?
Keep it short and to the point. 1.19. What is the ratio of the Primary completion rate (% of total enrollments) in Kuwait in 2003 to that in 2004?
Ensure brevity in your answer.  1. What is the ratio of the Primary completion rate (% of total enrollments) of Europe(all income levels) in 2003 to that in 2005?
Your response must be concise. 0.99. What is the ratio of the Primary completion rate (% of total enrollments) in Pacific island small states in 2003 to that in 2005?
Ensure brevity in your answer.  0.98. What is the ratio of the Primary completion rate (% of total enrollments) in Cyprus in 2003 to that in 2005?
Provide a short and direct response. 1.03. What is the ratio of the Primary completion rate (% of total enrollments) of Kuwait in 2003 to that in 2005?
Keep it short and to the point. 0.97. What is the ratio of the Primary completion rate (% of total enrollments) of Pacific island small states in 2004 to that in 2005?
Provide a short and direct response. 0.99. What is the ratio of the Primary completion rate (% of total enrollments) in Cyprus in 2004 to that in 2005?
Provide a short and direct response. 0.87. What is the ratio of the Primary completion rate (% of total enrollments) of Kuwait in 2004 to that in 2005?
Keep it short and to the point. 0.96. What is the difference between the highest and the second highest Primary completion rate (% of total enrollments) of Europe(all income levels)?
Offer a terse response. 0.29. What is the difference between the highest and the second highest Primary completion rate (% of total enrollments) of Pacific island small states?
Make the answer very short. 1.01. What is the difference between the highest and the second highest Primary completion rate (% of total enrollments) of Cyprus?
Ensure brevity in your answer.  2.29. What is the difference between the highest and the second highest Primary completion rate (% of total enrollments) in Kuwait?
Provide a short and direct response. 1.72. What is the difference between the highest and the lowest Primary completion rate (% of total enrollments) in Europe(all income levels)?
Offer a very short reply. 2.56. What is the difference between the highest and the lowest Primary completion rate (% of total enrollments) of Pacific island small states?
Offer a very short reply. 8.89. What is the difference between the highest and the lowest Primary completion rate (% of total enrollments) of Cyprus?
Your answer should be very brief. 16.19. What is the difference between the highest and the lowest Primary completion rate (% of total enrollments) in Kuwait?
Your response must be concise. 14.07. 